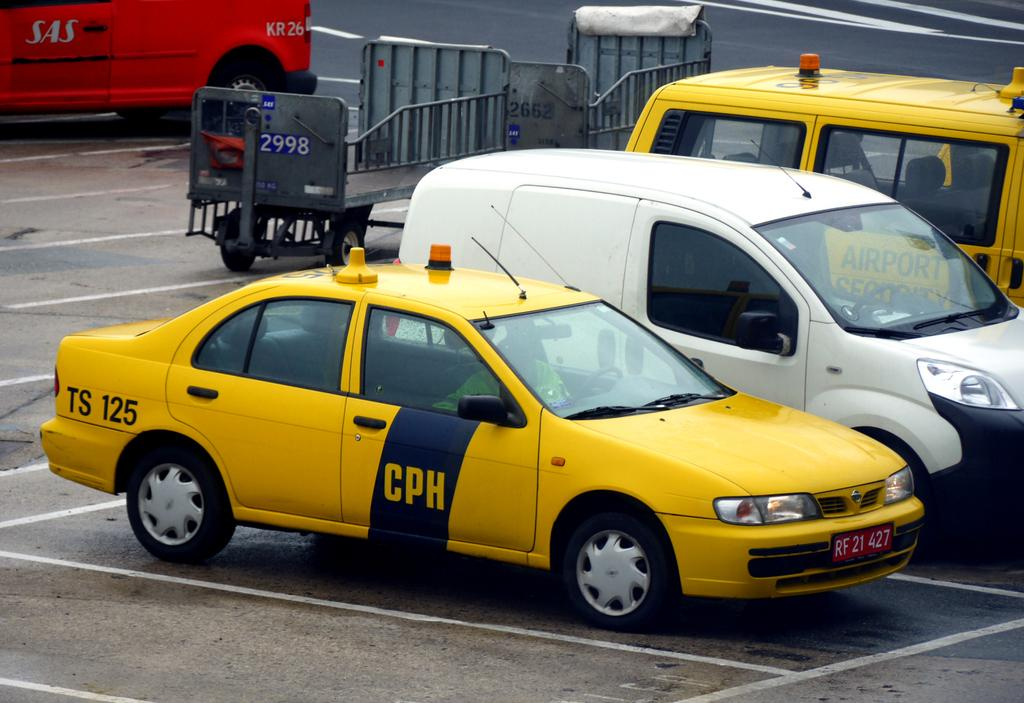<image>
Create a compact narrative representing the image presented. A yellow CPH car is parked by a white van. 